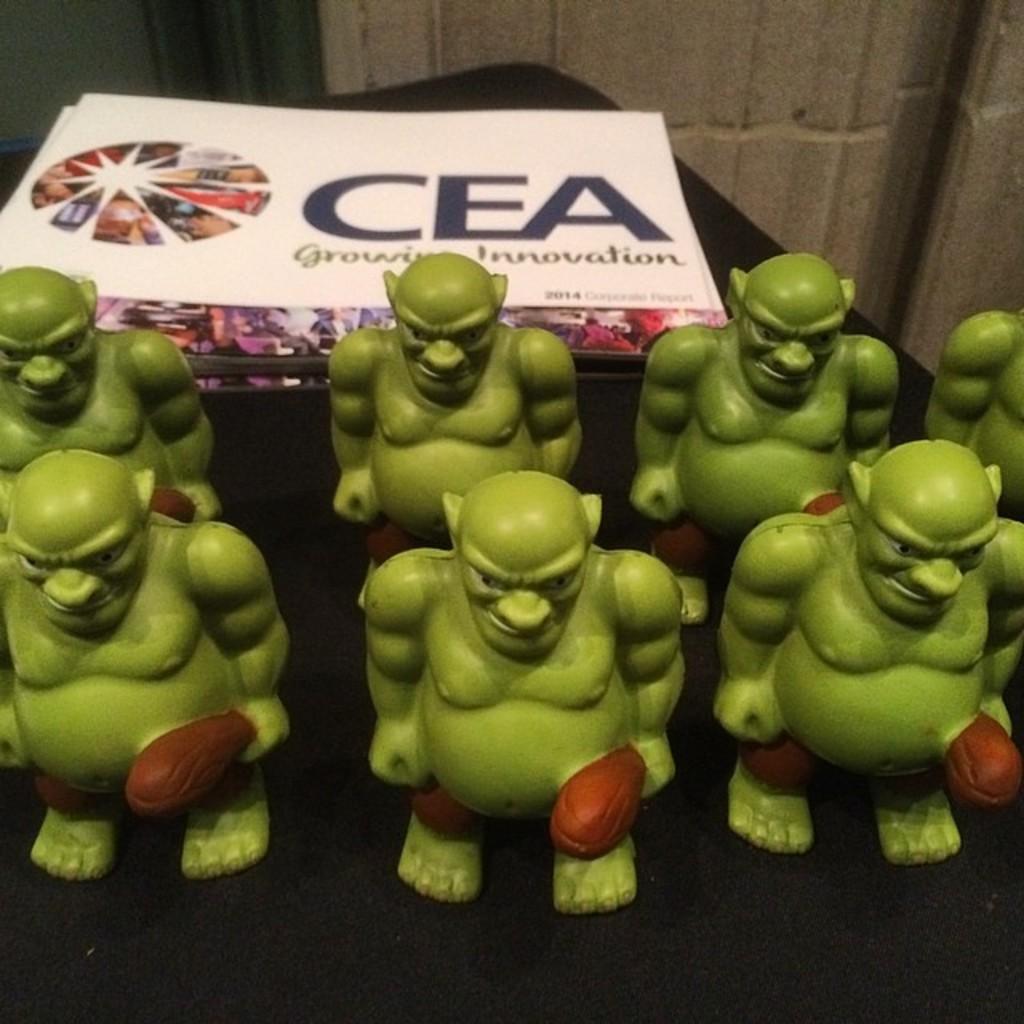Could you give a brief overview of what you see in this image? In the center of the image there are toys on the table. In the background of the image there is wall. 